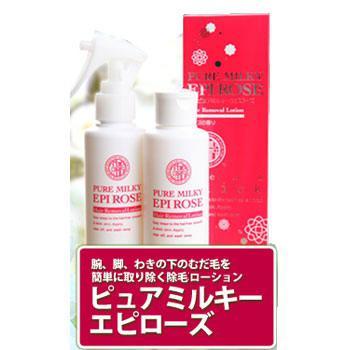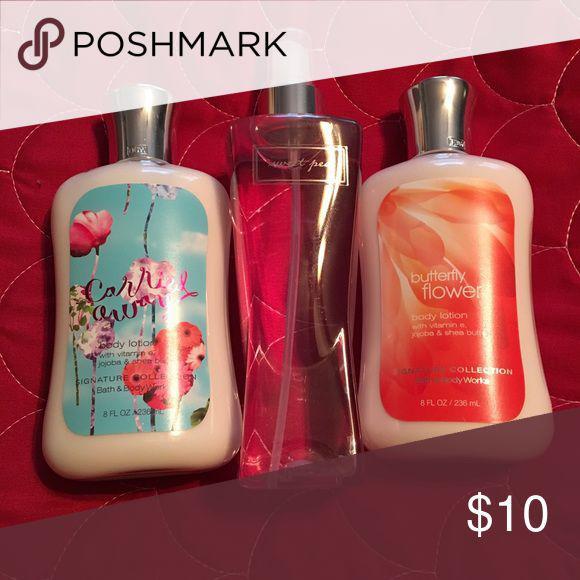The first image is the image on the left, the second image is the image on the right. For the images displayed, is the sentence "An image with no more than four items includes exactly one product that stands on its cap." factually correct? Answer yes or no. No. The first image is the image on the left, the second image is the image on the right. Evaluate the accuracy of this statement regarding the images: "One of the images shows four or more products.". Is it true? Answer yes or no. No. 